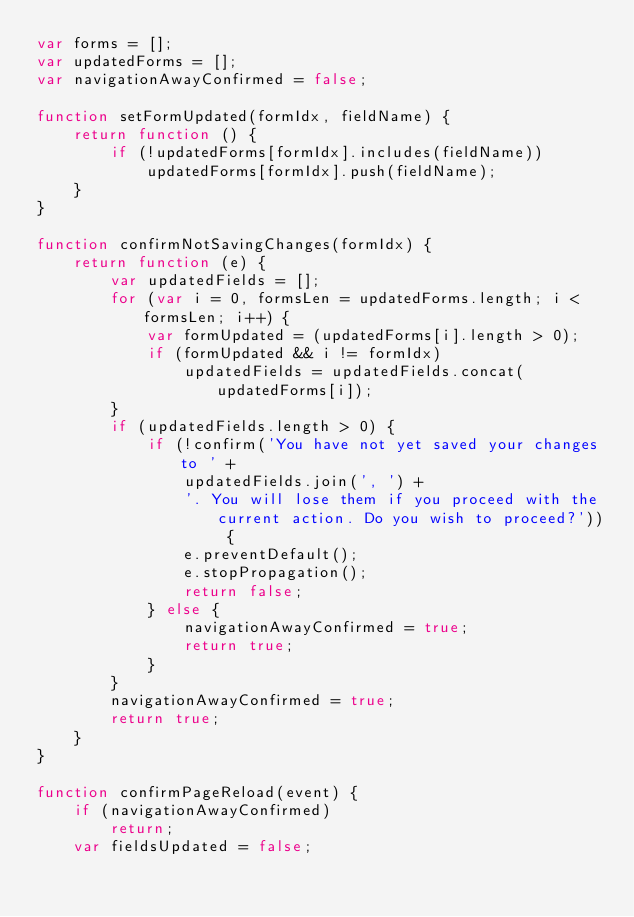<code> <loc_0><loc_0><loc_500><loc_500><_JavaScript_>var forms = [];
var updatedForms = [];
var navigationAwayConfirmed = false;

function setFormUpdated(formIdx, fieldName) {
    return function () {
        if (!updatedForms[formIdx].includes(fieldName))
            updatedForms[formIdx].push(fieldName);
    }
}

function confirmNotSavingChanges(formIdx) {
    return function (e) {
        var updatedFields = [];
        for (var i = 0, formsLen = updatedForms.length; i < formsLen; i++) {
            var formUpdated = (updatedForms[i].length > 0);
            if (formUpdated && i != formIdx)
                updatedFields = updatedFields.concat(updatedForms[i]);
        }
        if (updatedFields.length > 0) {
            if (!confirm('You have not yet saved your changes to ' +
                updatedFields.join(', ') +
                '. You will lose them if you proceed with the current action. Do you wish to proceed?')) {
                e.preventDefault();
                e.stopPropagation();
                return false;
            } else {
                navigationAwayConfirmed = true;
                return true;
            }
        }
        navigationAwayConfirmed = true;
        return true;
    }
}

function confirmPageReload(event) {
    if (navigationAwayConfirmed)
        return;
    var fieldsUpdated = false;</code> 